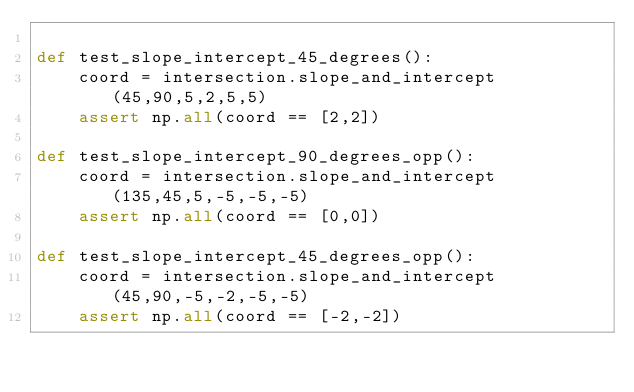Convert code to text. <code><loc_0><loc_0><loc_500><loc_500><_Python_>
def test_slope_intercept_45_degrees():
    coord = intersection.slope_and_intercept(45,90,5,2,5,5)
    assert np.all(coord == [2,2])

def test_slope_intercept_90_degrees_opp():
    coord = intersection.slope_and_intercept(135,45,5,-5,-5,-5)
    assert np.all(coord == [0,0])

def test_slope_intercept_45_degrees_opp():
    coord = intersection.slope_and_intercept(45,90,-5,-2,-5,-5)
    assert np.all(coord == [-2,-2])</code> 